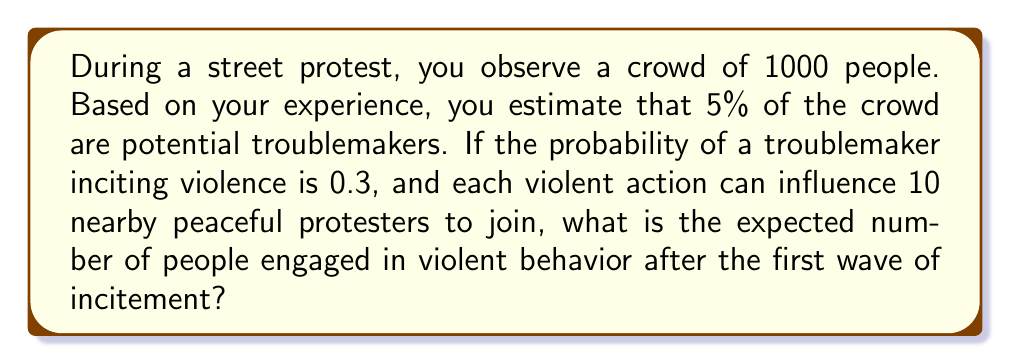Can you solve this math problem? Let's break this down step-by-step:

1) First, calculate the number of potential troublemakers:
   $1000 \times 5\% = 1000 \times 0.05 = 50$ troublemakers

2) The probability of a troublemaker inciting violence is 0.3, so the expected number of troublemakers who actually incite violence is:
   $50 \times 0.3 = 15$ active instigators

3) Each violent action influences 10 nearby peaceful protesters. So the number of additional people engaged in violent behavior is:
   $15 \times 10 = 150$ newly violent protesters

4) The total number of people engaged in violent behavior is the sum of the active instigators and the newly violent protesters:
   $15 + 150 = 165$

Therefore, the expected number of people engaged in violent behavior after the first wave of incitement is 165.
Answer: 165 people 